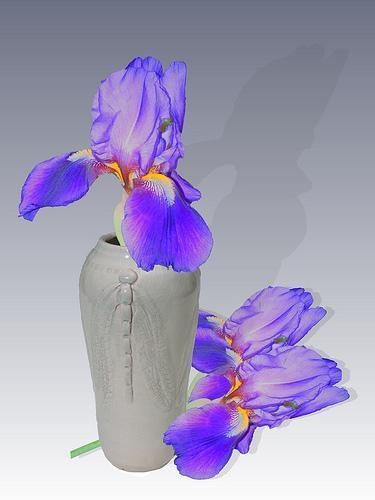How many vases are there?
Give a very brief answer. 1. 